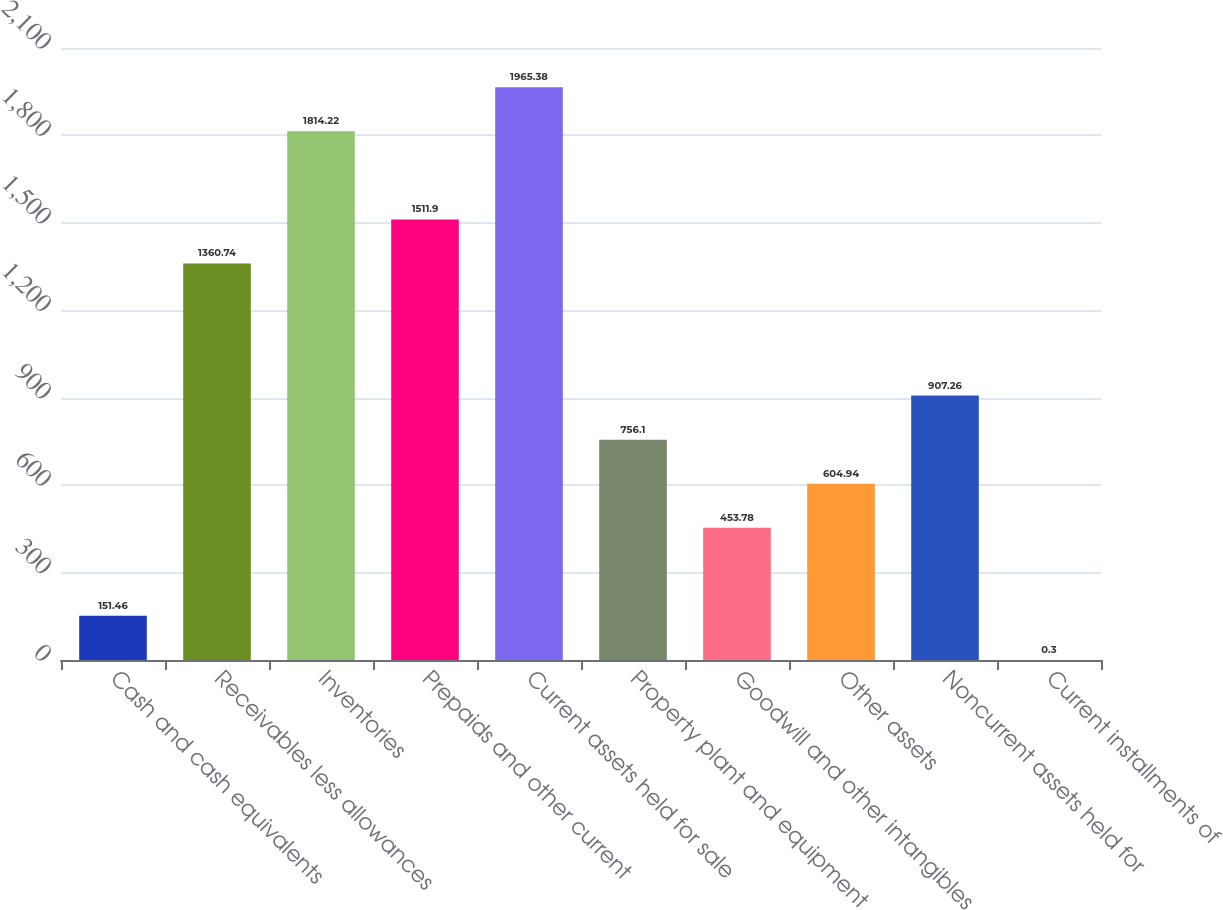<chart> <loc_0><loc_0><loc_500><loc_500><bar_chart><fcel>Cash and cash equivalents<fcel>Receivables less allowances<fcel>Inventories<fcel>Prepaids and other current<fcel>Current assets held for sale<fcel>Property plant and equipment<fcel>Goodwill and other intangibles<fcel>Other assets<fcel>Noncurrent assets held for<fcel>Current installments of<nl><fcel>151.46<fcel>1360.74<fcel>1814.22<fcel>1511.9<fcel>1965.38<fcel>756.1<fcel>453.78<fcel>604.94<fcel>907.26<fcel>0.3<nl></chart> 